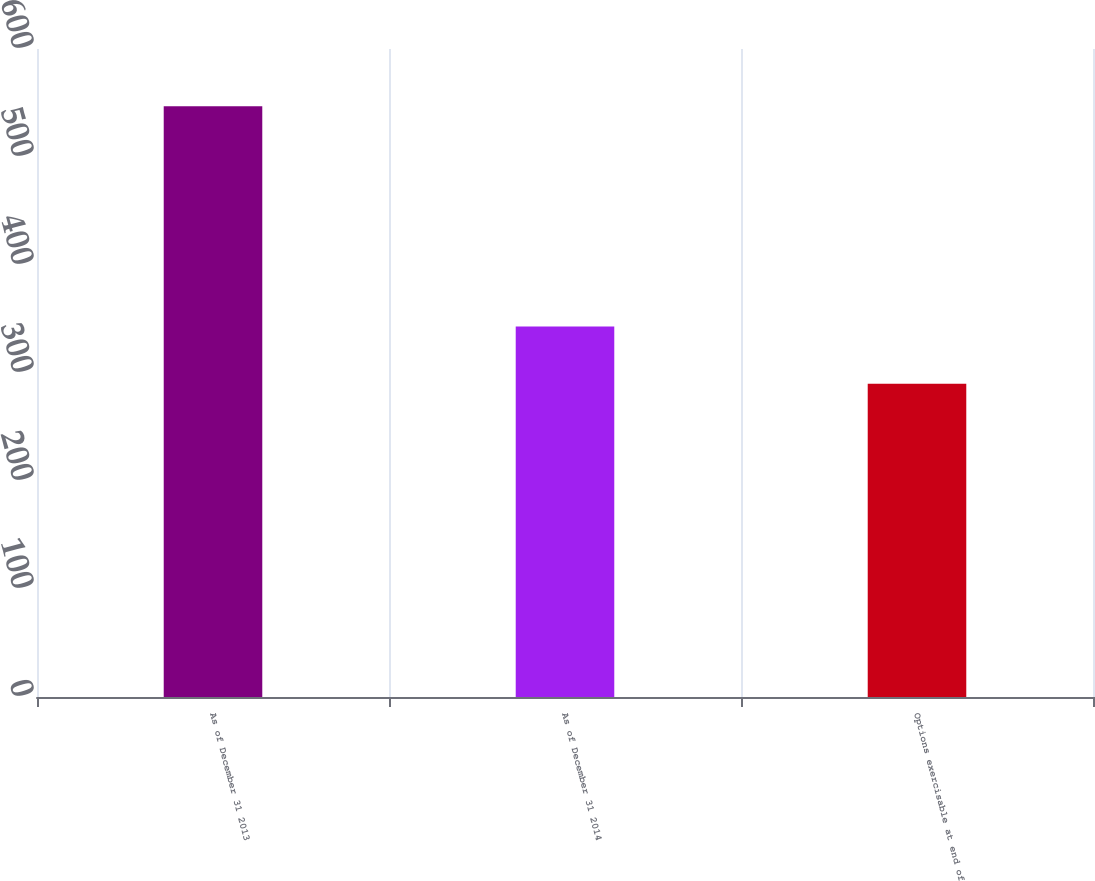<chart> <loc_0><loc_0><loc_500><loc_500><bar_chart><fcel>As of December 31 2013<fcel>As of December 31 2014<fcel>Options exercisable at end of<nl><fcel>547<fcel>343<fcel>290<nl></chart> 